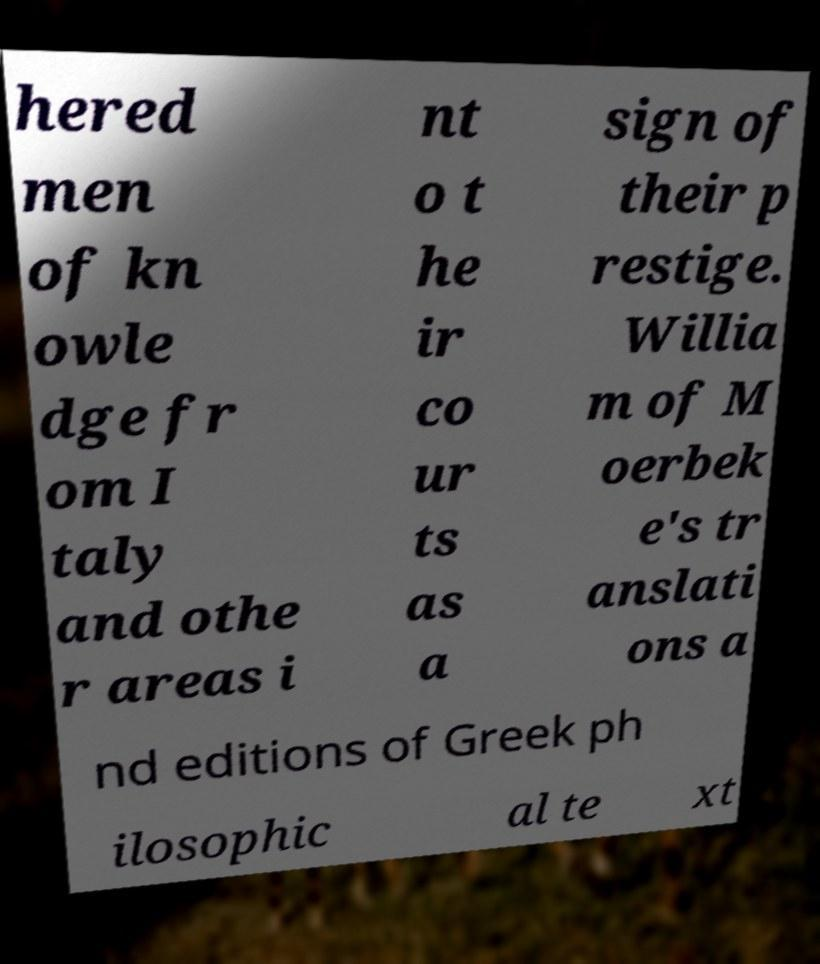Please identify and transcribe the text found in this image. hered men of kn owle dge fr om I taly and othe r areas i nt o t he ir co ur ts as a sign of their p restige. Willia m of M oerbek e's tr anslati ons a nd editions of Greek ph ilosophic al te xt 